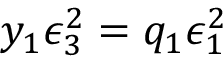Convert formula to latex. <formula><loc_0><loc_0><loc_500><loc_500>y _ { 1 } \epsilon _ { 3 } ^ { 2 } = q _ { 1 } \epsilon _ { 1 } ^ { 2 }</formula> 